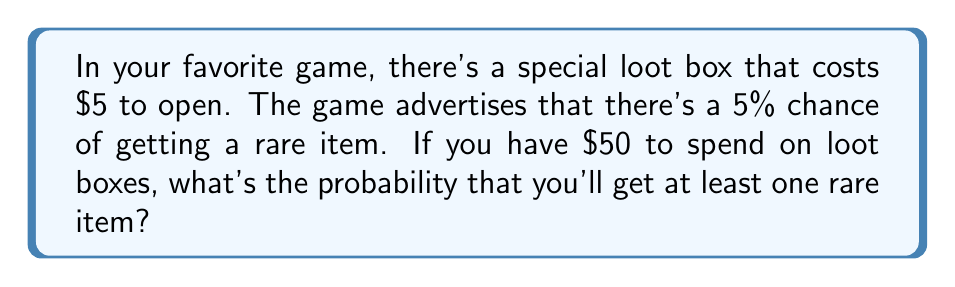Show me your answer to this math problem. Let's approach this step-by-step:

1) First, we need to determine how many loot boxes you can open with $50. Since each box costs $5:
   Number of boxes = $50 / $5 = 10 boxes

2) The probability of getting a rare item from one box is 5% or 0.05.

3) We're looking for the probability of getting at least one rare item, which is easier to calculate by first finding the probability of getting no rare items and then subtracting that from 1.

4) The probability of not getting a rare item from one box is:
   $1 - 0.05 = 0.95$ or 95%

5) For all 10 boxes to not contain a rare item, this needs to happen 10 times in a row. We can calculate this using the multiplication rule of probability:

   $P(\text{no rare items in 10 boxes}) = 0.95^{10}$

6) Now we can calculate the probability of getting at least one rare item:

   $P(\text{at least one rare item}) = 1 - P(\text{no rare items})$
   
   $= 1 - 0.95^{10}$

7) Let's calculate this:
   $1 - 0.95^{10} = 1 - 0.5987 = 0.4013$

8) Converting to a percentage:
   $0.4013 * 100 = 40.13\%$

Therefore, the probability of getting at least one rare item from 10 loot boxes is about 40.13%.
Answer: The probability of getting at least one rare item is approximately $40.13\%$. 